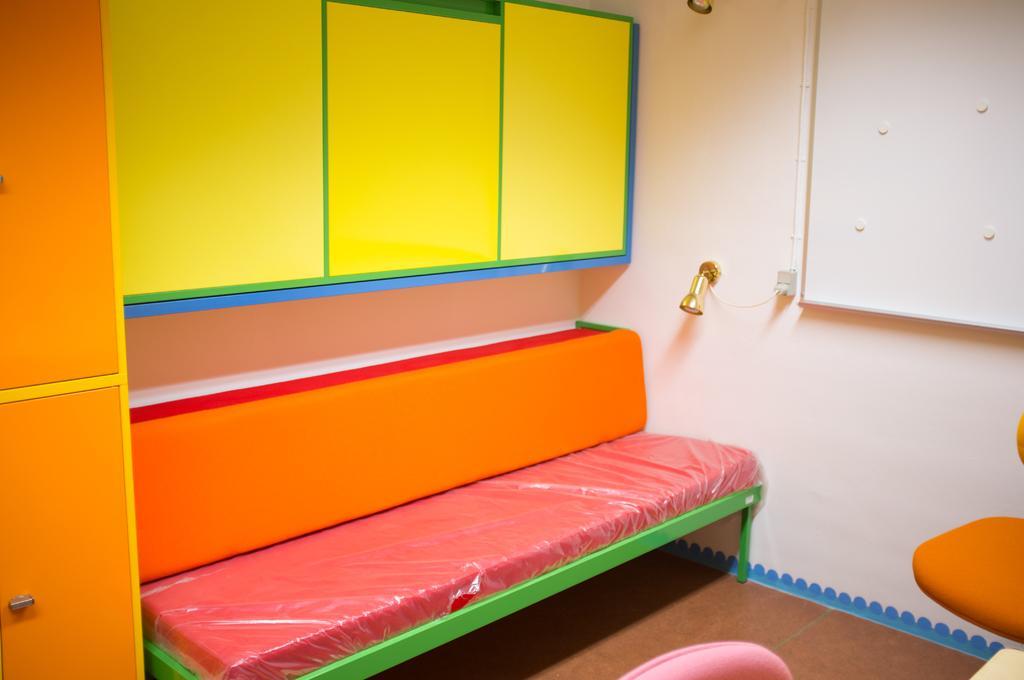Describe this image in one or two sentences. In this image we can see a sofa, cupboards, light, chairs, board and wall. 